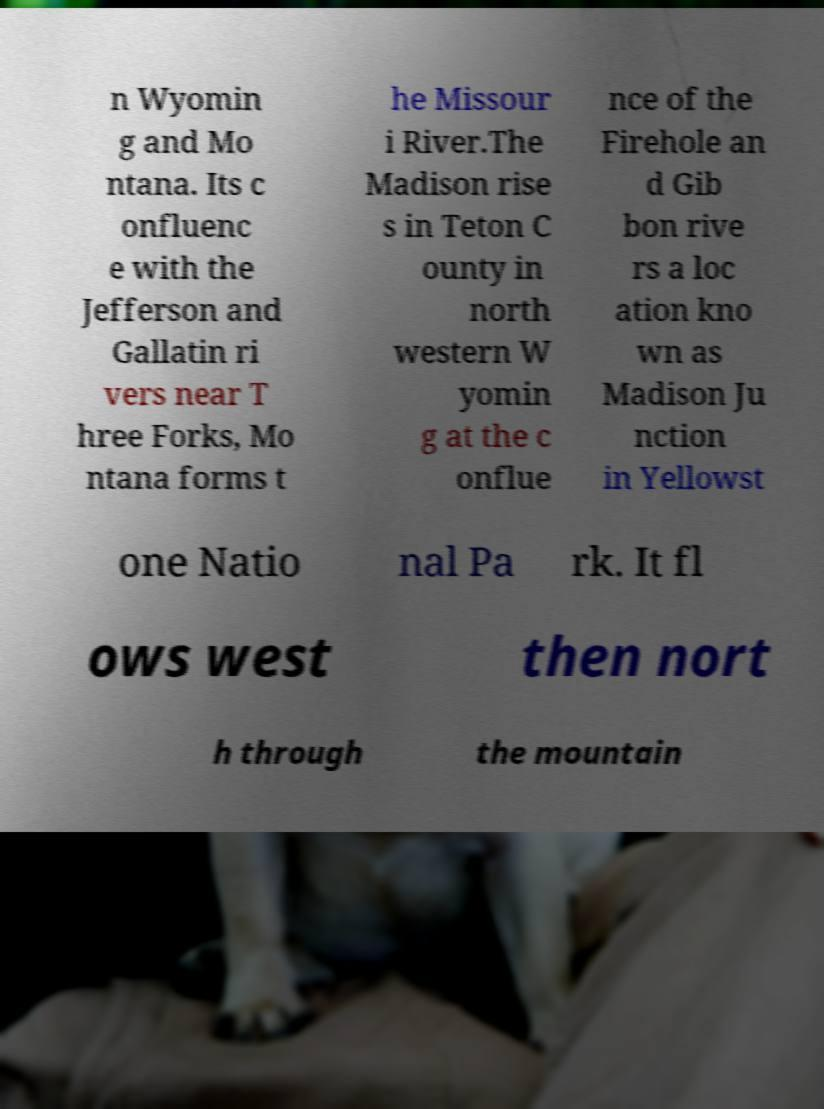Please read and relay the text visible in this image. What does it say? n Wyomin g and Mo ntana. Its c onfluenc e with the Jefferson and Gallatin ri vers near T hree Forks, Mo ntana forms t he Missour i River.The Madison rise s in Teton C ounty in north western W yomin g at the c onflue nce of the Firehole an d Gib bon rive rs a loc ation kno wn as Madison Ju nction in Yellowst one Natio nal Pa rk. It fl ows west then nort h through the mountain 